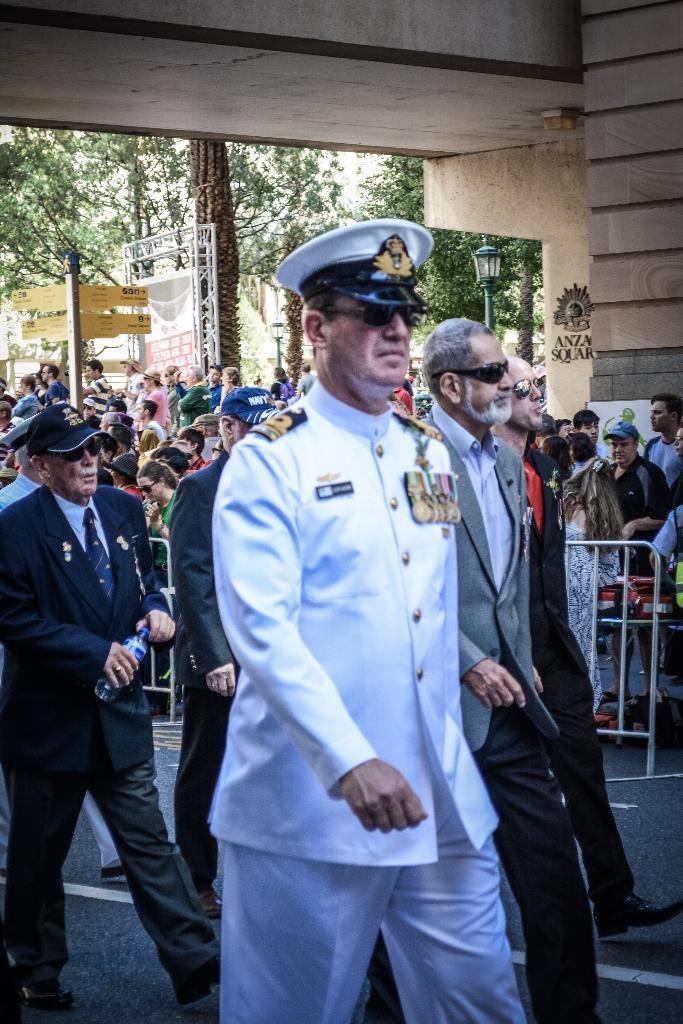Can you describe this image briefly? This image consists of few people walking on the road. In the front, the man is wearing a white dress along with a white cap. In the background, there is a huge crowd. In the middle, there is a fence. At the top, there is a roof made up of wood. In the background, there are many trees. 